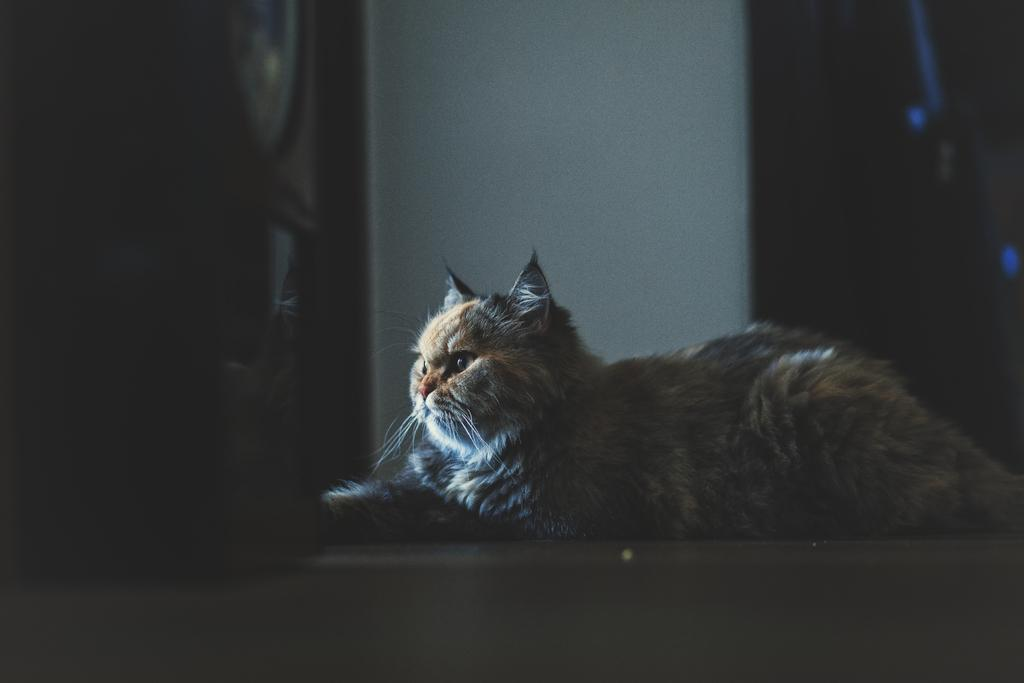What animal is sitting on the floor in the image? There is a cat sitting on the floor in the image. What is the color of the wall in the image? There is a white wall in the image. Can you describe the object on the left side of the image? Unfortunately, the facts provided do not give enough information to describe the object on the left side of the image. What type of pleasure can be seen on the cat's face in the image? There is no indication of the cat's emotions or facial expressions in the image, so it cannot be determined if the cat is experiencing pleasure. 